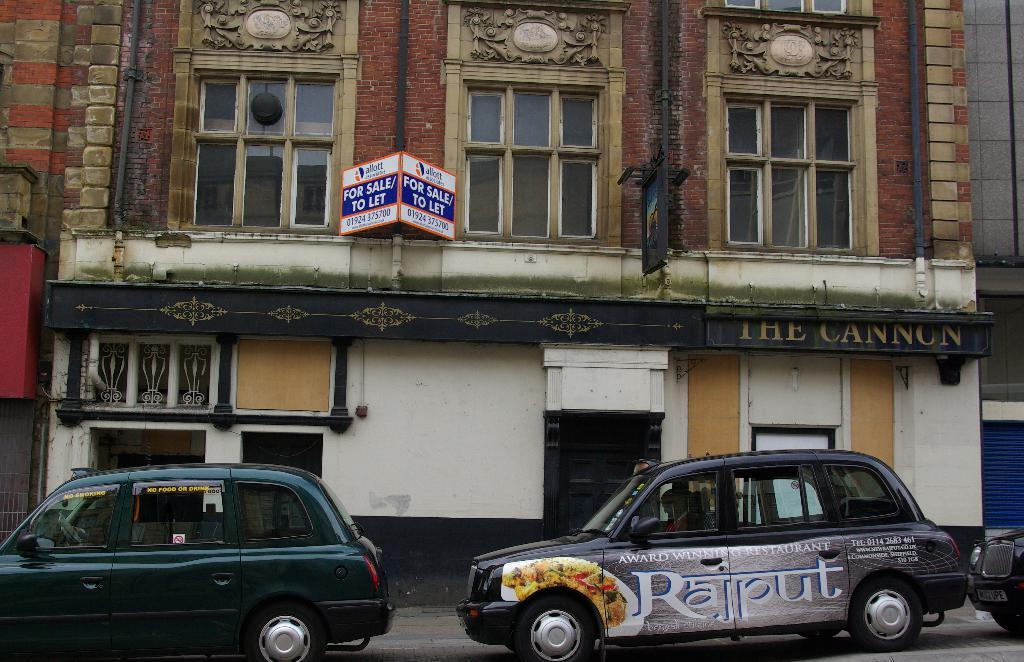<image>
Render a clear and concise summary of the photo. a car that has the letter R on the front of it 